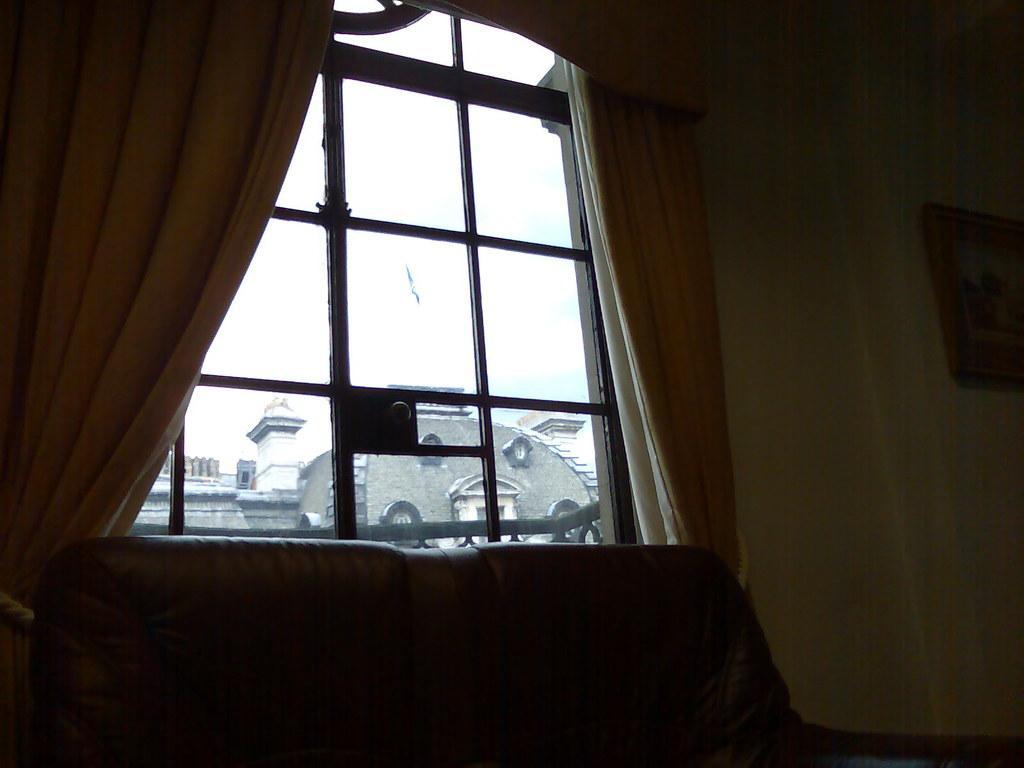In one or two sentences, can you explain what this image depicts? In this picture we can see curtains, sofa and a frame on the wall, in the background we can see a building. 